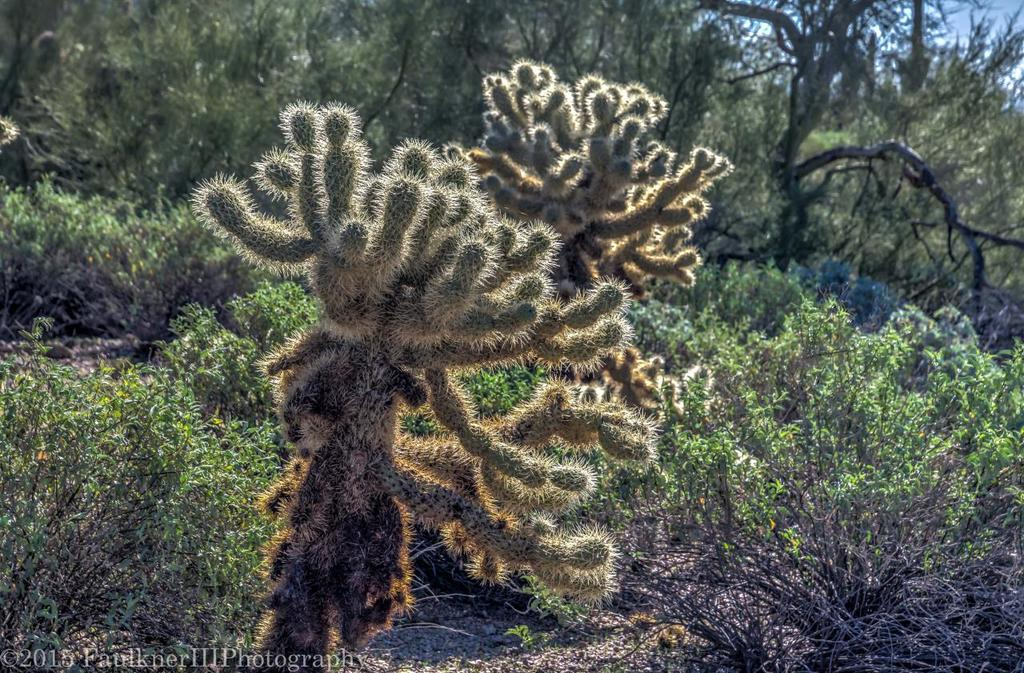What type of vegetation can be seen in the image? There are plants and trees in the image. What is on the ground in the image? There are objects on the ground in the image. What can be seen in the background of the image? The sky is visible in the background of the image. Is there any text or marking on the image? Yes, there is a watermark on the left side of the image. What type of fuel is being used by the ray in the image? There is no ray or fuel present in the image. Is there a veil covering any part of the image? No, there is no veil present in the image. 